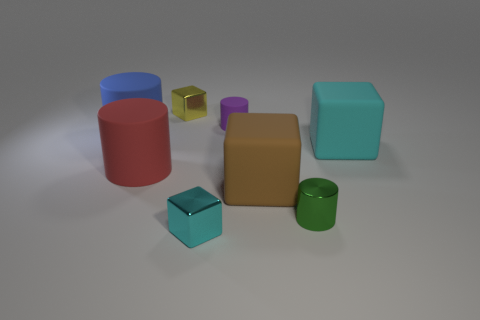Add 2 big red objects. How many objects exist? 10 Subtract all tiny green shiny objects. Subtract all cylinders. How many objects are left? 3 Add 4 metal cubes. How many metal cubes are left? 6 Add 4 cyan shiny cubes. How many cyan shiny cubes exist? 5 Subtract all cyan blocks. How many blocks are left? 2 Subtract all matte cylinders. How many cylinders are left? 1 Subtract 0 yellow balls. How many objects are left? 8 Subtract 3 blocks. How many blocks are left? 1 Subtract all red cylinders. Subtract all blue balls. How many cylinders are left? 3 Subtract all gray cylinders. How many red blocks are left? 0 